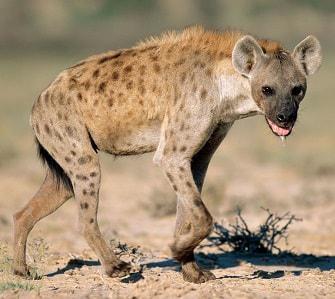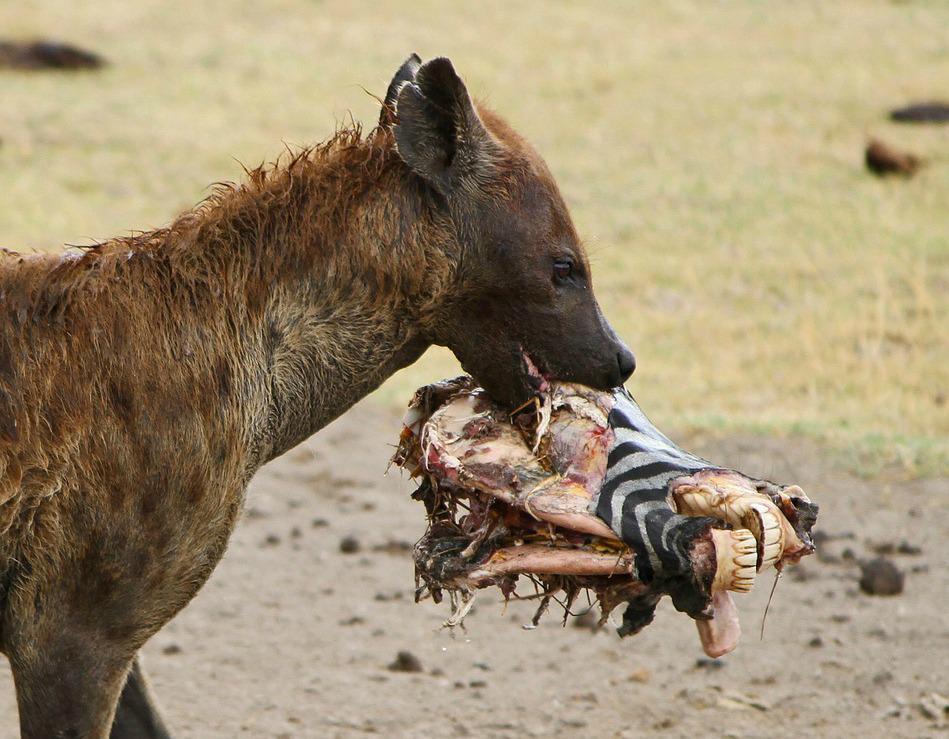The first image is the image on the left, the second image is the image on the right. Examine the images to the left and right. Is the description "One of the images contains a hyena eating a dead animal." accurate? Answer yes or no. Yes. The first image is the image on the left, the second image is the image on the right. Analyze the images presented: Is the assertion "No hyena is facing left." valid? Answer yes or no. Yes. 